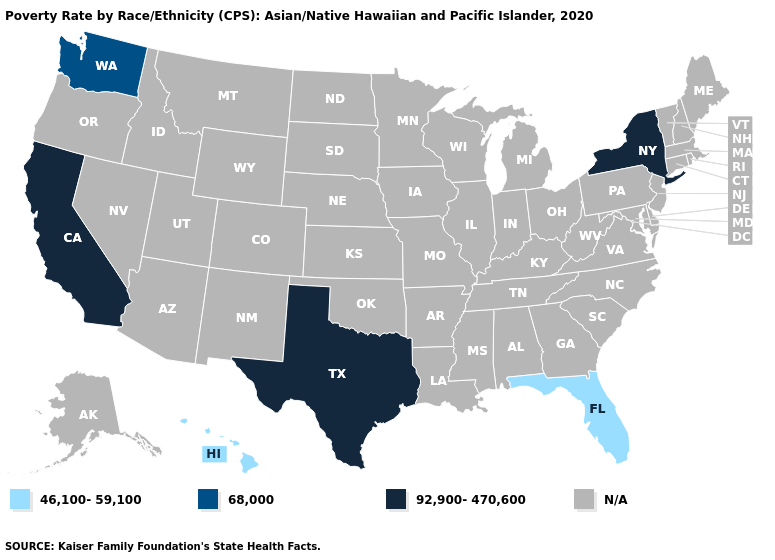Name the states that have a value in the range N/A?
Short answer required. Alabama, Alaska, Arizona, Arkansas, Colorado, Connecticut, Delaware, Georgia, Idaho, Illinois, Indiana, Iowa, Kansas, Kentucky, Louisiana, Maine, Maryland, Massachusetts, Michigan, Minnesota, Mississippi, Missouri, Montana, Nebraska, Nevada, New Hampshire, New Jersey, New Mexico, North Carolina, North Dakota, Ohio, Oklahoma, Oregon, Pennsylvania, Rhode Island, South Carolina, South Dakota, Tennessee, Utah, Vermont, Virginia, West Virginia, Wisconsin, Wyoming. Which states have the lowest value in the USA?
Keep it brief. Florida, Hawaii. Name the states that have a value in the range 92,900-470,600?
Short answer required. California, New York, Texas. What is the highest value in the USA?
Quick response, please. 92,900-470,600. Is the legend a continuous bar?
Give a very brief answer. No. Name the states that have a value in the range 68,000?
Quick response, please. Washington. Which states hav the highest value in the Northeast?
Keep it brief. New York. Does Hawaii have the lowest value in the West?
Be succinct. Yes. 